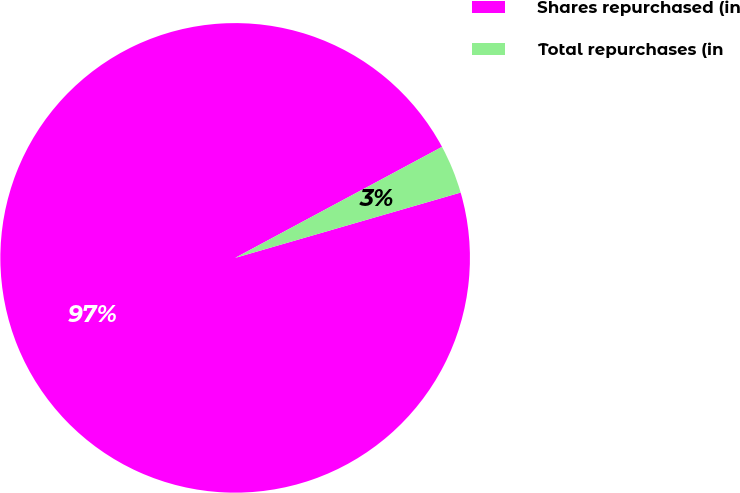Convert chart to OTSL. <chart><loc_0><loc_0><loc_500><loc_500><pie_chart><fcel>Shares repurchased (in<fcel>Total repurchases (in<nl><fcel>96.65%<fcel>3.35%<nl></chart> 